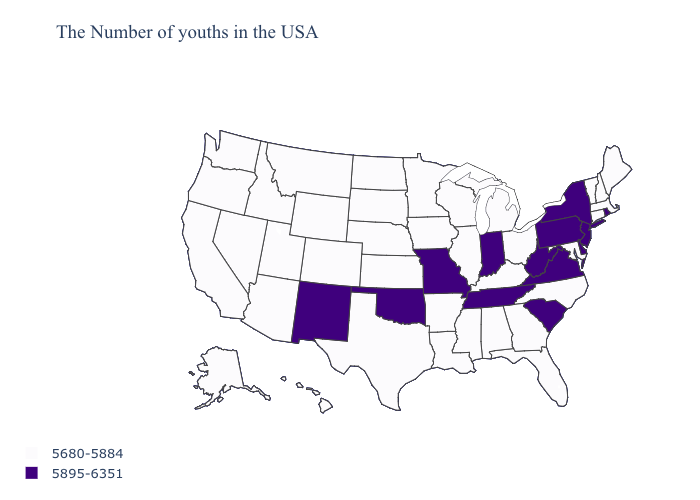Name the states that have a value in the range 5680-5884?
Answer briefly. Maine, Massachusetts, New Hampshire, Vermont, Connecticut, Maryland, North Carolina, Ohio, Florida, Georgia, Michigan, Kentucky, Alabama, Wisconsin, Illinois, Mississippi, Louisiana, Arkansas, Minnesota, Iowa, Kansas, Nebraska, Texas, South Dakota, North Dakota, Wyoming, Colorado, Utah, Montana, Arizona, Idaho, Nevada, California, Washington, Oregon, Alaska, Hawaii. Does New Jersey have the lowest value in the USA?
Be succinct. No. Does New Hampshire have a lower value than Oklahoma?
Quick response, please. Yes. Name the states that have a value in the range 5680-5884?
Write a very short answer. Maine, Massachusetts, New Hampshire, Vermont, Connecticut, Maryland, North Carolina, Ohio, Florida, Georgia, Michigan, Kentucky, Alabama, Wisconsin, Illinois, Mississippi, Louisiana, Arkansas, Minnesota, Iowa, Kansas, Nebraska, Texas, South Dakota, North Dakota, Wyoming, Colorado, Utah, Montana, Arizona, Idaho, Nevada, California, Washington, Oregon, Alaska, Hawaii. Name the states that have a value in the range 5895-6351?
Be succinct. Rhode Island, New York, New Jersey, Delaware, Pennsylvania, Virginia, South Carolina, West Virginia, Indiana, Tennessee, Missouri, Oklahoma, New Mexico. Among the states that border Pennsylvania , does New Jersey have the lowest value?
Write a very short answer. No. Name the states that have a value in the range 5680-5884?
Quick response, please. Maine, Massachusetts, New Hampshire, Vermont, Connecticut, Maryland, North Carolina, Ohio, Florida, Georgia, Michigan, Kentucky, Alabama, Wisconsin, Illinois, Mississippi, Louisiana, Arkansas, Minnesota, Iowa, Kansas, Nebraska, Texas, South Dakota, North Dakota, Wyoming, Colorado, Utah, Montana, Arizona, Idaho, Nevada, California, Washington, Oregon, Alaska, Hawaii. Name the states that have a value in the range 5895-6351?
Write a very short answer. Rhode Island, New York, New Jersey, Delaware, Pennsylvania, Virginia, South Carolina, West Virginia, Indiana, Tennessee, Missouri, Oklahoma, New Mexico. Name the states that have a value in the range 5895-6351?
Be succinct. Rhode Island, New York, New Jersey, Delaware, Pennsylvania, Virginia, South Carolina, West Virginia, Indiana, Tennessee, Missouri, Oklahoma, New Mexico. Does the map have missing data?
Concise answer only. No. Does California have a higher value than Montana?
Short answer required. No. Among the states that border Vermont , does New Hampshire have the lowest value?
Keep it brief. Yes. Does the first symbol in the legend represent the smallest category?
Concise answer only. Yes. Does South Dakota have the lowest value in the USA?
Be succinct. Yes. 